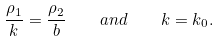<formula> <loc_0><loc_0><loc_500><loc_500>\frac { \rho _ { 1 } } { k } = \frac { \rho _ { 2 } } { b } \quad a n d \quad k = k _ { 0 } .</formula> 